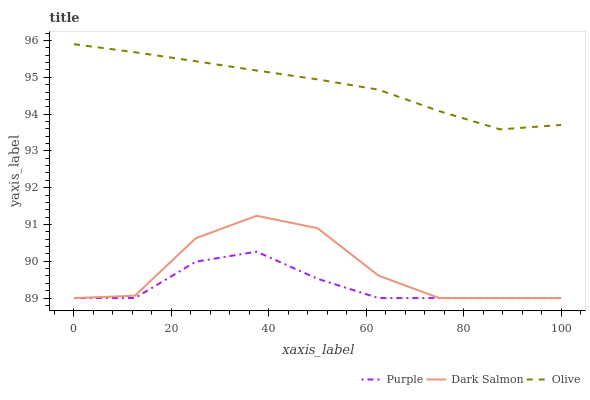Does Purple have the minimum area under the curve?
Answer yes or no. Yes. Does Olive have the maximum area under the curve?
Answer yes or no. Yes. Does Dark Salmon have the minimum area under the curve?
Answer yes or no. No. Does Dark Salmon have the maximum area under the curve?
Answer yes or no. No. Is Olive the smoothest?
Answer yes or no. Yes. Is Dark Salmon the roughest?
Answer yes or no. Yes. Is Dark Salmon the smoothest?
Answer yes or no. No. Is Olive the roughest?
Answer yes or no. No. Does Purple have the lowest value?
Answer yes or no. Yes. Does Olive have the lowest value?
Answer yes or no. No. Does Olive have the highest value?
Answer yes or no. Yes. Does Dark Salmon have the highest value?
Answer yes or no. No. Is Dark Salmon less than Olive?
Answer yes or no. Yes. Is Olive greater than Purple?
Answer yes or no. Yes. Does Purple intersect Dark Salmon?
Answer yes or no. Yes. Is Purple less than Dark Salmon?
Answer yes or no. No. Is Purple greater than Dark Salmon?
Answer yes or no. No. Does Dark Salmon intersect Olive?
Answer yes or no. No. 